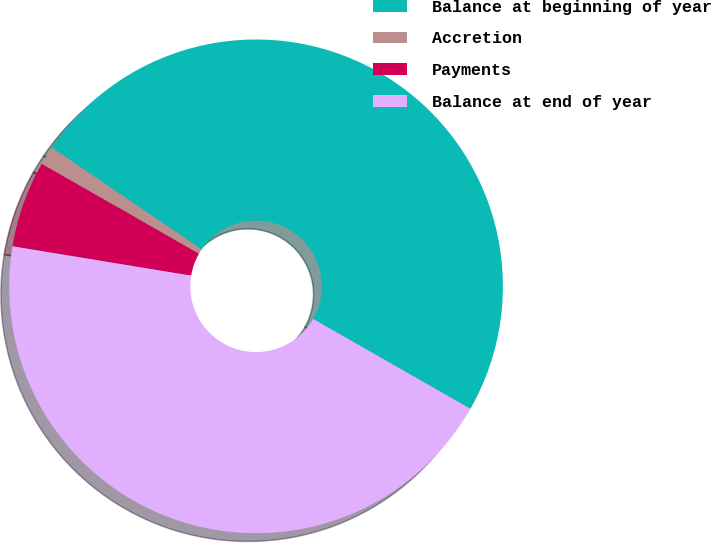Convert chart to OTSL. <chart><loc_0><loc_0><loc_500><loc_500><pie_chart><fcel>Balance at beginning of year<fcel>Accretion<fcel>Payments<fcel>Balance at end of year<nl><fcel>48.77%<fcel>1.23%<fcel>5.67%<fcel>44.33%<nl></chart> 